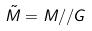<formula> <loc_0><loc_0><loc_500><loc_500>\tilde { M } = M / / G</formula> 